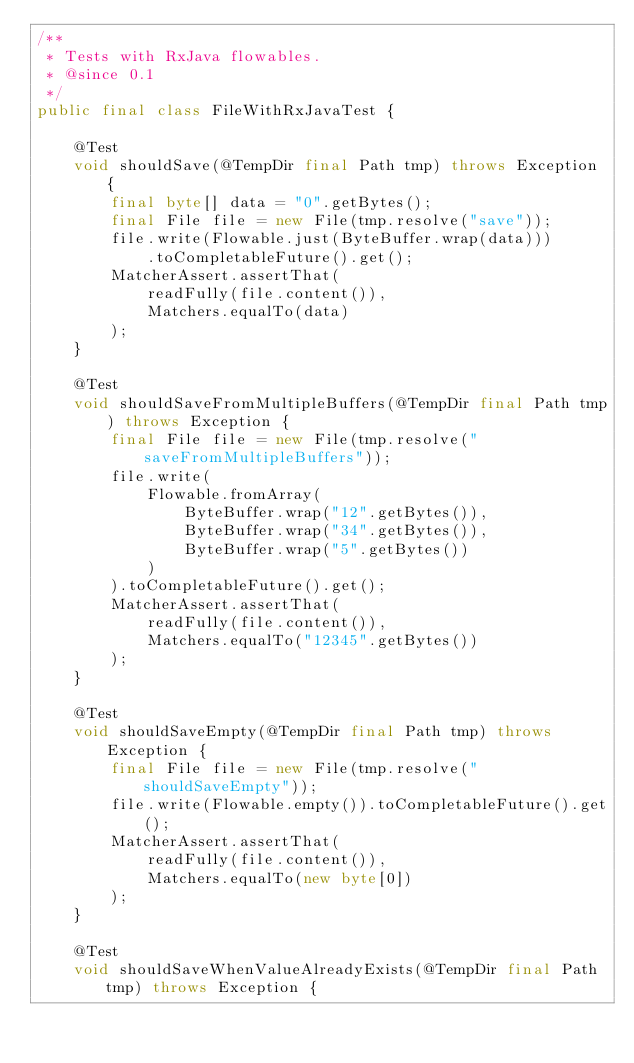Convert code to text. <code><loc_0><loc_0><loc_500><loc_500><_Java_>/**
 * Tests with RxJava flowables.
 * @since 0.1
 */
public final class FileWithRxJavaTest {

    @Test
    void shouldSave(@TempDir final Path tmp) throws Exception {
        final byte[] data = "0".getBytes();
        final File file = new File(tmp.resolve("save"));
        file.write(Flowable.just(ByteBuffer.wrap(data)))
            .toCompletableFuture().get();
        MatcherAssert.assertThat(
            readFully(file.content()),
            Matchers.equalTo(data)
        );
    }

    @Test
    void shouldSaveFromMultipleBuffers(@TempDir final Path tmp) throws Exception {
        final File file = new File(tmp.resolve("saveFromMultipleBuffers"));
        file.write(
            Flowable.fromArray(
                ByteBuffer.wrap("12".getBytes()),
                ByteBuffer.wrap("34".getBytes()),
                ByteBuffer.wrap("5".getBytes())
            )
        ).toCompletableFuture().get();
        MatcherAssert.assertThat(
            readFully(file.content()),
            Matchers.equalTo("12345".getBytes())
        );
    }

    @Test
    void shouldSaveEmpty(@TempDir final Path tmp) throws Exception {
        final File file = new File(tmp.resolve("shouldSaveEmpty"));
        file.write(Flowable.empty()).toCompletableFuture().get();
        MatcherAssert.assertThat(
            readFully(file.content()),
            Matchers.equalTo(new byte[0])
        );
    }

    @Test
    void shouldSaveWhenValueAlreadyExists(@TempDir final Path tmp) throws Exception {</code> 